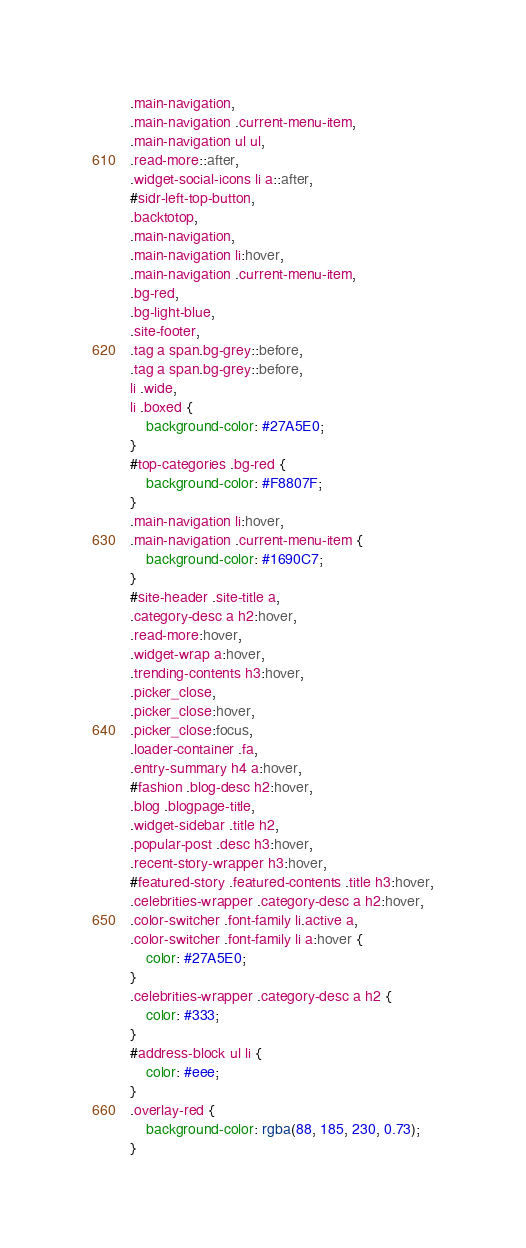Convert code to text. <code><loc_0><loc_0><loc_500><loc_500><_CSS_>.main-navigation,
.main-navigation .current-menu-item, 
.main-navigation ul ul,
.read-more::after, 
.widget-social-icons li a::after,
#sidr-left-top-button,
.backtotop,
.main-navigation,
.main-navigation li:hover, 
.main-navigation .current-menu-item,
.bg-red,
.bg-light-blue,
.site-footer,
.tag a span.bg-grey::before, 
.tag a span.bg-grey::before,
li .wide, 
li .boxed {
    background-color: #27A5E0;
}
#top-categories .bg-red {
    background-color: #F8807F;
}
.main-navigation li:hover,
.main-navigation .current-menu-item {
	background-color: #1690C7;
}
#site-header .site-title a,
.category-desc a h2:hover,
.read-more:hover, 
.widget-wrap a:hover,
.trending-contents h3:hover,
.picker_close, 
.picker_close:hover, 
.picker_close:focus,
.loader-container .fa,
.entry-summary h4 a:hover,
#fashion .blog-desc h2:hover,
.blog .blogpage-title,
.widget-sidebar .title h2,
.popular-post .desc h3:hover,
.recent-story-wrapper h3:hover,
#featured-story .featured-contents .title h3:hover,
.celebrities-wrapper .category-desc a h2:hover,
.color-switcher .font-family li.active a, 
.color-switcher .font-family li a:hover {
	color: #27A5E0;
}
.celebrities-wrapper .category-desc a h2 {
	color: #333;
}
#address-block ul li {
	color: #eee;
}
.overlay-red {
	background-color: rgba(88, 185, 230, 0.73);
}
</code> 